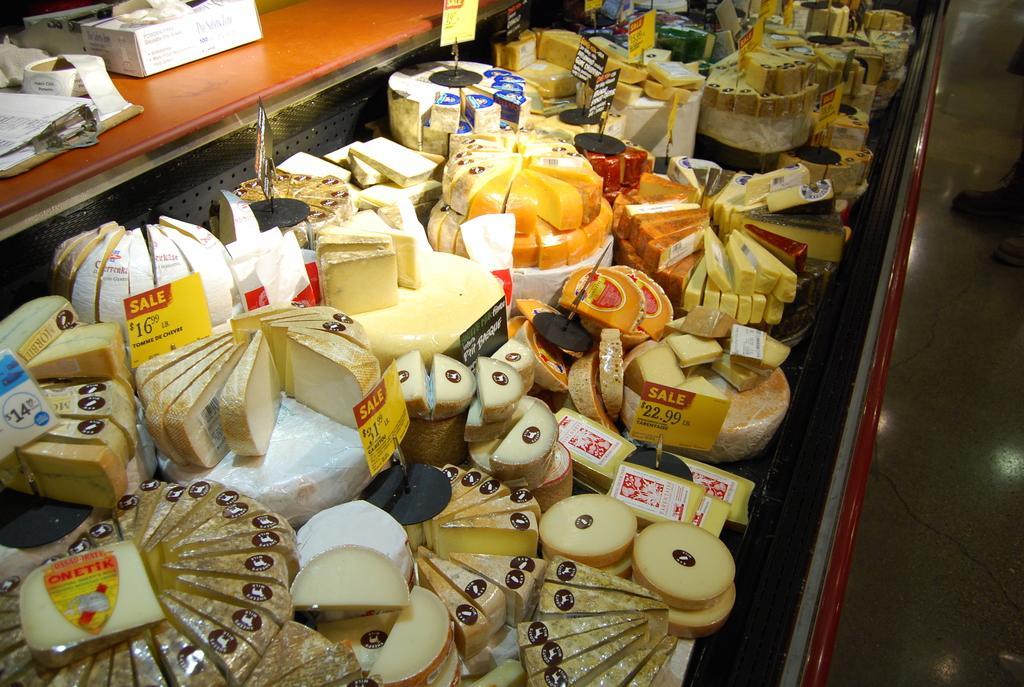Can you describe this image briefly? In the picture I can see many food items are placed on the surface and I can see price tags. Here I can see few more objects like pad, papers and a box are placed on the brown color surface. 